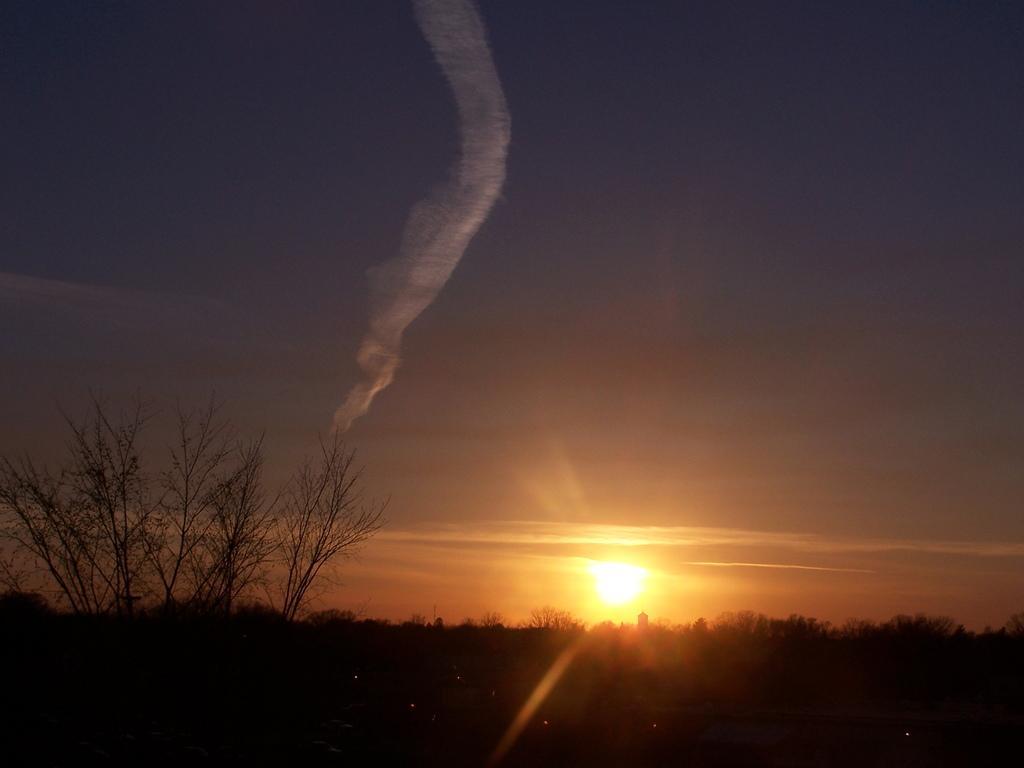Please provide a concise description of this image. In the image in the center, we can see the sky, sun, trees and smoke. 